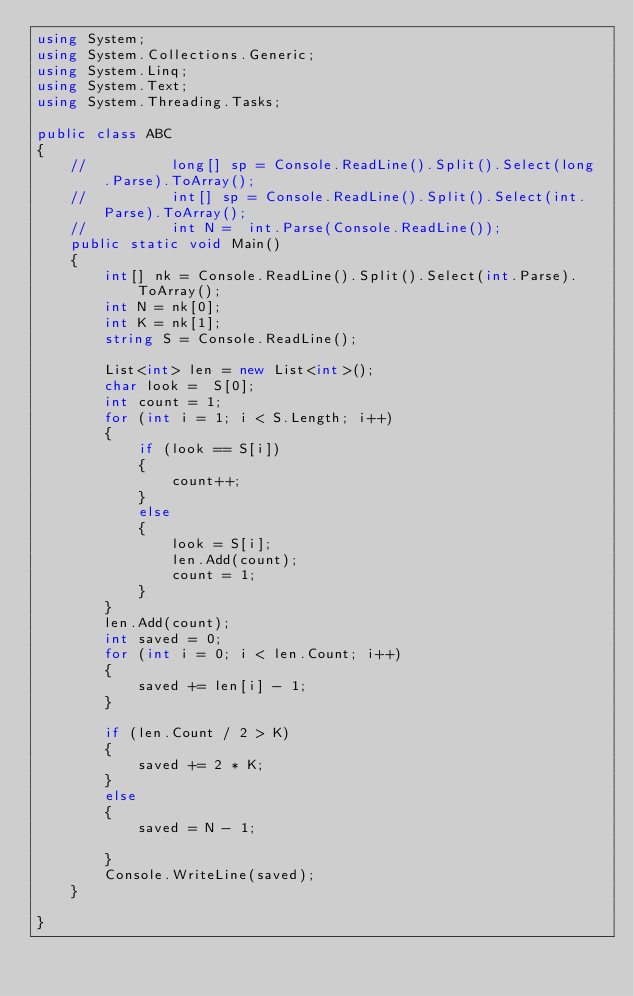Convert code to text. <code><loc_0><loc_0><loc_500><loc_500><_C#_>using System;
using System.Collections.Generic;
using System.Linq;
using System.Text;
using System.Threading.Tasks;

public class ABC
{
    //          long[] sp = Console.ReadLine().Split().Select(long .Parse).ToArray();
    //          int[] sp = Console.ReadLine().Split().Select(int.Parse).ToArray();
    //          int N =  int.Parse(Console.ReadLine());
    public static void Main()
    {
        int[] nk = Console.ReadLine().Split().Select(int.Parse).ToArray();
        int N = nk[0];
        int K = nk[1];
        string S = Console.ReadLine();

        List<int> len = new List<int>();
        char look =  S[0];
        int count = 1;
        for (int i = 1; i < S.Length; i++)
        {
            if (look == S[i])
            {
                count++;
            }
            else
            {
                look = S[i];
                len.Add(count);
                count = 1;
            }
        }
        len.Add(count);
        int saved = 0;
        for (int i = 0; i < len.Count; i++)
        {
            saved += len[i] - 1;
        }

        if (len.Count / 2 > K)
        {
            saved += 2 * K;
        }
        else
        {
            saved = N - 1;

        }
        Console.WriteLine(saved);
    }

}


</code> 